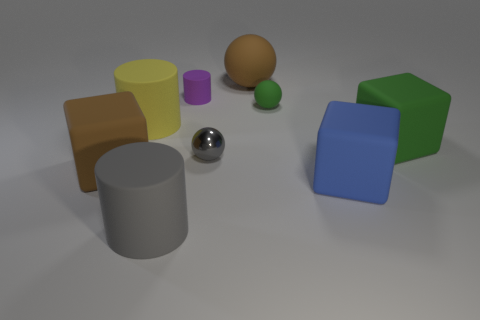What shape is the rubber thing that is the same color as the shiny sphere?
Keep it short and to the point. Cylinder. Are there any rubber objects on the right side of the big gray rubber object?
Make the answer very short. Yes. There is a big green matte object that is to the right of the large yellow rubber object; does it have the same shape as the brown matte thing in front of the metal ball?
Your response must be concise. Yes. There is another tiny object that is the same shape as the tiny green thing; what is it made of?
Provide a succinct answer. Metal. What number of cylinders are either large brown matte things or small matte objects?
Offer a terse response. 1. How many large yellow objects are the same material as the small cylinder?
Offer a terse response. 1. Do the green object on the right side of the tiny green rubber ball and the small object that is in front of the large yellow rubber cylinder have the same material?
Ensure brevity in your answer.  No. There is a large rubber cylinder behind the blue matte cube on the right side of the tiny cylinder; what number of large things are in front of it?
Ensure brevity in your answer.  4. There is a big cylinder in front of the gray metal sphere; is it the same color as the small thing that is in front of the green rubber cube?
Ensure brevity in your answer.  Yes. Is there any other thing of the same color as the tiny cylinder?
Give a very brief answer. No. 